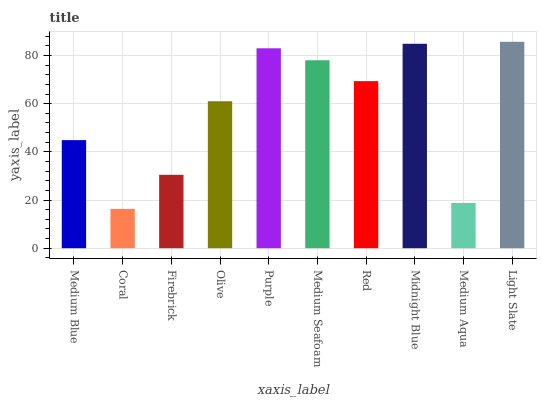Is Coral the minimum?
Answer yes or no. Yes. Is Light Slate the maximum?
Answer yes or no. Yes. Is Firebrick the minimum?
Answer yes or no. No. Is Firebrick the maximum?
Answer yes or no. No. Is Firebrick greater than Coral?
Answer yes or no. Yes. Is Coral less than Firebrick?
Answer yes or no. Yes. Is Coral greater than Firebrick?
Answer yes or no. No. Is Firebrick less than Coral?
Answer yes or no. No. Is Red the high median?
Answer yes or no. Yes. Is Olive the low median?
Answer yes or no. Yes. Is Firebrick the high median?
Answer yes or no. No. Is Medium Seafoam the low median?
Answer yes or no. No. 